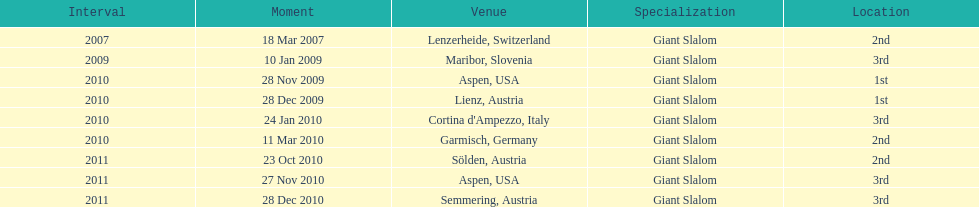Where was her first win? Aspen, USA. 